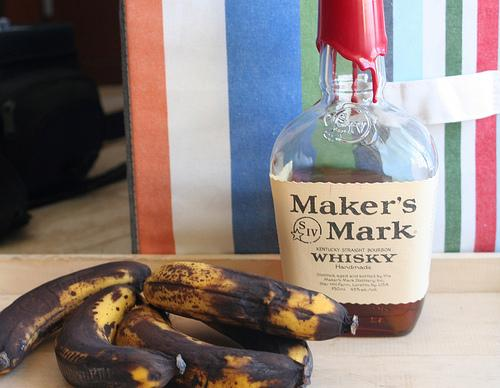Please describe the appearance of the striped wall in this photograph. The wall has multicolored vertical stripes in various widths, featuring a wide white stripe, a wide blue stripe, a narrow green stripe, and an orange stripe behind bananas. Analyze the relevance of the background elements in relation to the main objects of the image. The background elements like the multicolored striped wall add visual interest and contrast to the main objects, but they may also create clutter and potentially distract from the bananas and whisky bottle. How many bananas are there in the image and what is their condition? There are four overripe bananas in the image with yellow and brown colors, indicating they are bruised or rotten. Determine the overall quality of the image based on objects and their colors. The image appears to be in moderate quality with diverse colors and clear object descriptions, although there is a sense of clutter with many objects and colors present. Identify the types of materials from which the whisky bottle, table, and bananas are made. Whiskey bottle - glass, table - wood, bananas - organic fruit material. Count the number of objects mentioned in the image description and categorize them. There are 9 objects - 4 rotten bananas, 1 whisky bottle, 1 black bag, 1 table, 1 zipper, and 1 striped wall. What are the main objects interacting in this scene, and how do they interact? The main objects interacting are the whisky bottle and the overripe bananas, both resting on a wooden table, conveying a peculiar combination of items. Based on the description, what sentiment do you feel this image could evoke in the viewers? The image could evoke a feeling of disarray and decay with overripe bananas and mish-mash of striped colors on the wall. Detail the key features of the bottle with the word "whisky" written on it, such as its contents and label. The bottle has the word "whisky" on it along with "makers" and "mark." It contains brown whiskey and has a clear glass body, a red wax top, a tan label with black text, and an embossed circle in the glass. List the primary elements in the image along with their colors and position. Four overripe bananas with yellow and brown color on a wooden brown table, a clear glass bottle of Makers Mark whisky with a red wax top on the same table, and a multicolored striped wall with white, blue, green, and orange stripes behind the objects. 